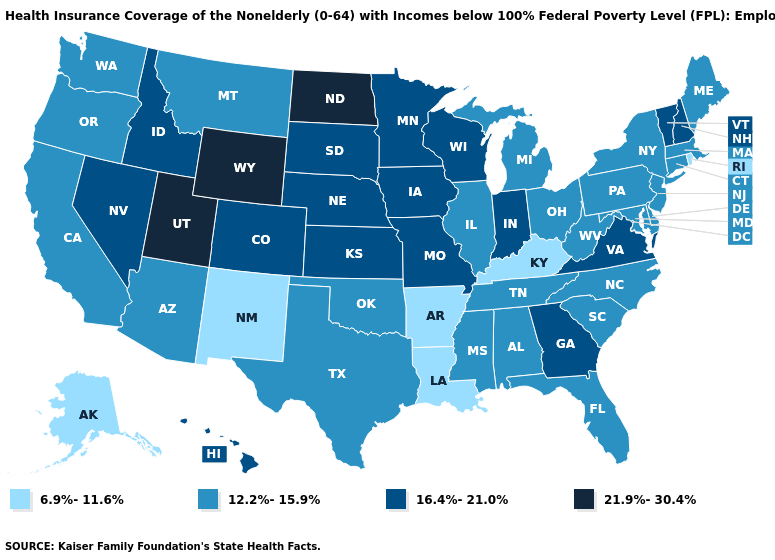Which states have the lowest value in the USA?
Keep it brief. Alaska, Arkansas, Kentucky, Louisiana, New Mexico, Rhode Island. What is the value of Pennsylvania?
Answer briefly. 12.2%-15.9%. Which states have the lowest value in the South?
Quick response, please. Arkansas, Kentucky, Louisiana. Among the states that border Louisiana , which have the highest value?
Give a very brief answer. Mississippi, Texas. How many symbols are there in the legend?
Quick response, please. 4. What is the highest value in the South ?
Write a very short answer. 16.4%-21.0%. Does Missouri have a higher value than Wyoming?
Write a very short answer. No. Does Louisiana have the lowest value in the USA?
Concise answer only. Yes. What is the value of Colorado?
Be succinct. 16.4%-21.0%. Among the states that border Utah , does Nevada have the highest value?
Keep it brief. No. Does Rhode Island have the highest value in the Northeast?
Write a very short answer. No. Name the states that have a value in the range 21.9%-30.4%?
Concise answer only. North Dakota, Utah, Wyoming. Which states have the lowest value in the MidWest?
Short answer required. Illinois, Michigan, Ohio. Does California have the highest value in the USA?
Write a very short answer. No. What is the lowest value in states that border Delaware?
Write a very short answer. 12.2%-15.9%. 